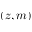Convert formula to latex. <formula><loc_0><loc_0><loc_500><loc_500>( z , m )</formula> 